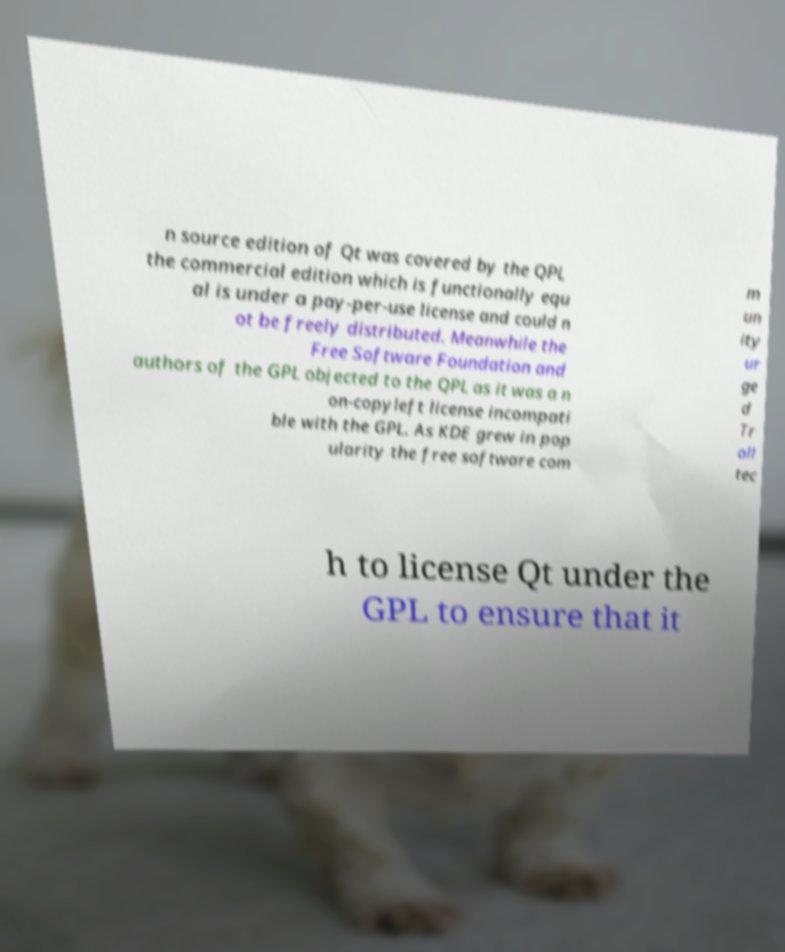What messages or text are displayed in this image? I need them in a readable, typed format. n source edition of Qt was covered by the QPL the commercial edition which is functionally equ al is under a pay-per-use license and could n ot be freely distributed. Meanwhile the Free Software Foundation and authors of the GPL objected to the QPL as it was a n on-copyleft license incompati ble with the GPL. As KDE grew in pop ularity the free software com m un ity ur ge d Tr oll tec h to license Qt under the GPL to ensure that it 